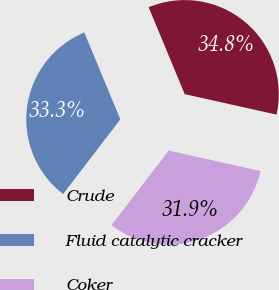Convert chart to OTSL. <chart><loc_0><loc_0><loc_500><loc_500><pie_chart><fcel>Crude<fcel>Fluid catalytic cracker<fcel>Coker<nl><fcel>34.75%<fcel>33.33%<fcel>31.92%<nl></chart> 